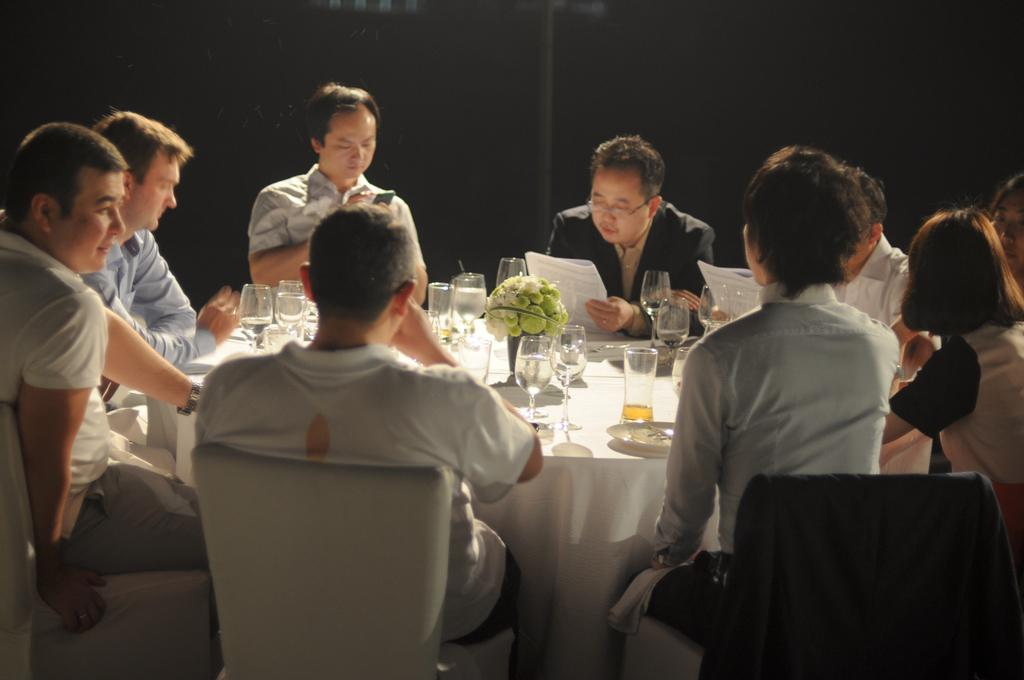What are the people in the image doing? There are people sitting on chairs around a table. What objects can be seen on the table? There are glasses, a flower vase, and plates on the table. What are the two men holding in their hands? The two men are holding paper in their hands. What are the two men doing with the paper? The two men are looking at the paper. How many birds are in the flock that is flying over the table in the image? There is no flock of birds visible in the image. What type of hair is visible on the people sitting around the table? The provided facts do not mention hair, so we cannot determine the type of hair visible on the people in the image. 